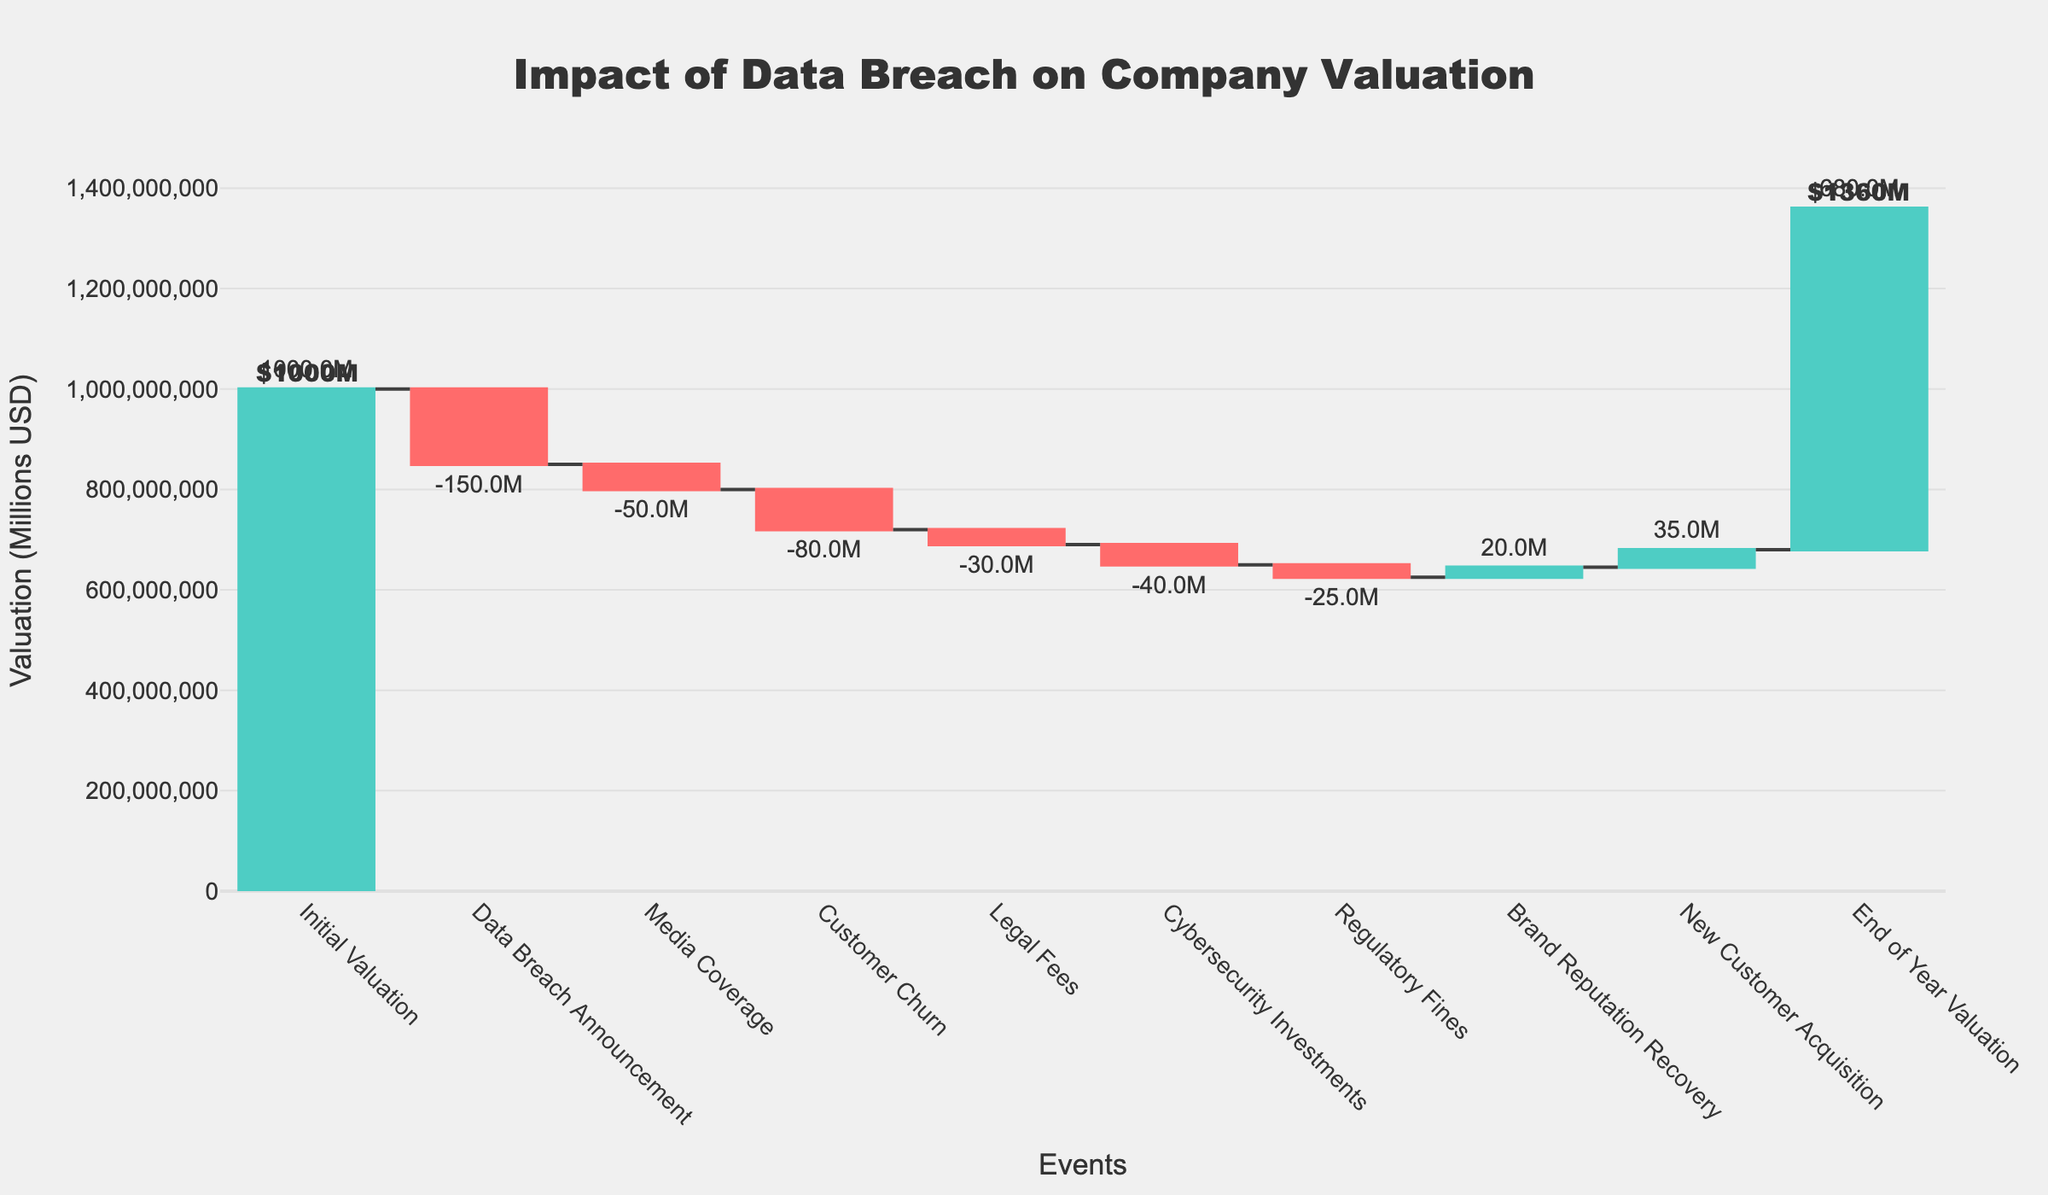What is the title of the chart? The title is displayed prominently at the top of the chart in large font. It reads "Impact of Data Breach on Company Valuation".
Answer: Impact of Data Breach on Company Valuation What is the initial valuation of the company in millions? The initial valuation is marked at the far left and annotated with the initial value, which is $1000 million.
Answer: 1000M How many events are represented in the waterfall chart? By counting the number of categories listed on the x-axis from left to right, there are 9 events (Initial Valuation + 8 subsequent events + End of Year Valuation).
Answer: 9 What is the net impact of the Data Breach Announcement on the company's valuation? After the Data Breach Announcement, there is a decrease of $150 million, as indicated by the red bar.
Answer: -150M What is the total decrease in valuation due to negative events? Summing up the negative values: -150M (Data Breach Announcement) + -50M (Media Coverage) + -80M (Customer Churn) + -30M (Legal Fees) + -40M (Cybersecurity Investments) + -25M (Regulatory Fines) = -375M.
Answer: -375M Which event has the smallest negative impact on the valuation? Among the negative-value events, Regulatory Fines show the smallest decrease in valuation, marked as -25M.
Answer: Regulatory Fines What is the total positive impact on the valuation from Brand Reputation Recovery and New Customer Acquisition? Adding up the two positive impacts: 20M (Brand Reputation Recovery) + 35M (New Customer Acquisition) = 55M.
Answer: 55M What is the percentage decrease in valuation from the initial valuation to the end of year valuation? The initial valuation is $1000M and the end of year valuation is $680M. The decrease is $1000M - $680M = $320M. The percentage decrease is ($320M / $1000M) * 100 = 32%.
Answer: 32% How does the impact of Media Coverage compare to the impact of Customer Churn? Media Coverage results in a decrease of $50M, while Customer Churn results in a decrease of $80M. Thus, Customer Churn has a larger negative impact by $30M.
Answer: Customer Churn (-80M) has a larger impact than Media Coverage (-50M) by 30M What is the cumulative valuation after Cybersecurity Investments? The initial valuation is $1000M. After applying the negative impacts sequentially until Cybersecurity Investments (-150M - 50M - 80M - 30M - 40M), the cumulative valuation is $650M.
Answer: 650M 